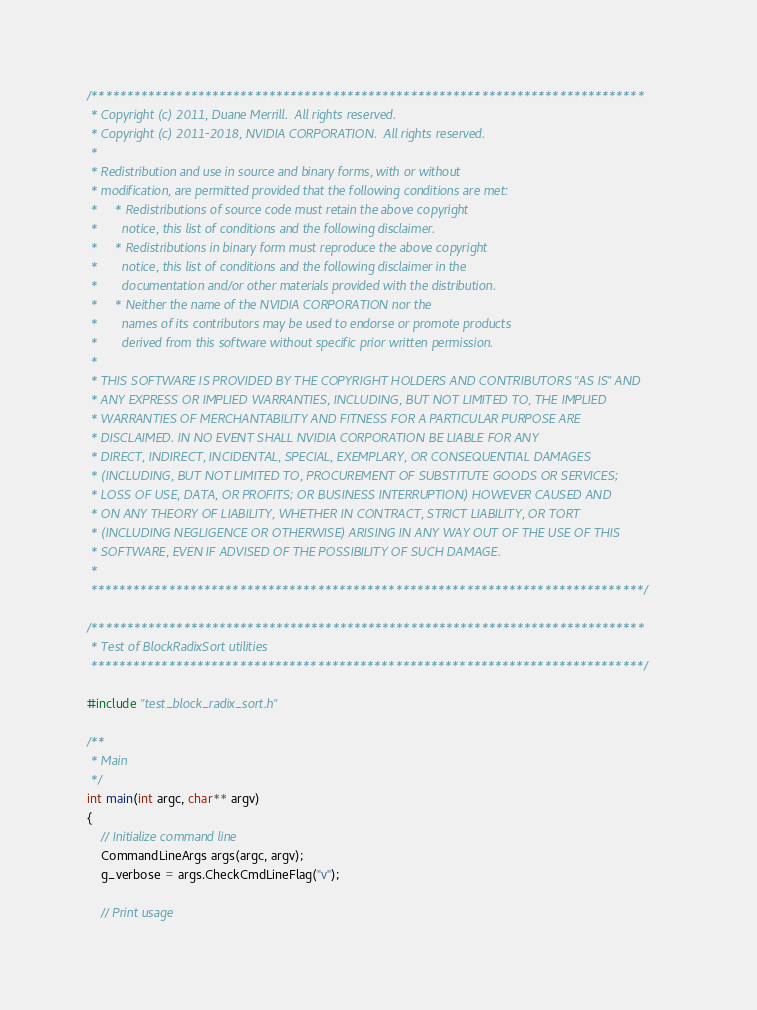Convert code to text. <code><loc_0><loc_0><loc_500><loc_500><_Cuda_>/******************************************************************************
 * Copyright (c) 2011, Duane Merrill.  All rights reserved.
 * Copyright (c) 2011-2018, NVIDIA CORPORATION.  All rights reserved.
 *
 * Redistribution and use in source and binary forms, with or without
 * modification, are permitted provided that the following conditions are met:
 *     * Redistributions of source code must retain the above copyright
 *       notice, this list of conditions and the following disclaimer.
 *     * Redistributions in binary form must reproduce the above copyright
 *       notice, this list of conditions and the following disclaimer in the
 *       documentation and/or other materials provided with the distribution.
 *     * Neither the name of the NVIDIA CORPORATION nor the
 *       names of its contributors may be used to endorse or promote products
 *       derived from this software without specific prior written permission.
 *
 * THIS SOFTWARE IS PROVIDED BY THE COPYRIGHT HOLDERS AND CONTRIBUTORS "AS IS" AND
 * ANY EXPRESS OR IMPLIED WARRANTIES, INCLUDING, BUT NOT LIMITED TO, THE IMPLIED
 * WARRANTIES OF MERCHANTABILITY AND FITNESS FOR A PARTICULAR PURPOSE ARE
 * DISCLAIMED. IN NO EVENT SHALL NVIDIA CORPORATION BE LIABLE FOR ANY
 * DIRECT, INDIRECT, INCIDENTAL, SPECIAL, EXEMPLARY, OR CONSEQUENTIAL DAMAGES
 * (INCLUDING, BUT NOT LIMITED TO, PROCUREMENT OF SUBSTITUTE GOODS OR SERVICES;
 * LOSS OF USE, DATA, OR PROFITS; OR BUSINESS INTERRUPTION) HOWEVER CAUSED AND
 * ON ANY THEORY OF LIABILITY, WHETHER IN CONTRACT, STRICT LIABILITY, OR TORT
 * (INCLUDING NEGLIGENCE OR OTHERWISE) ARISING IN ANY WAY OUT OF THE USE OF THIS
 * SOFTWARE, EVEN IF ADVISED OF THE POSSIBILITY OF SUCH DAMAGE.
 *
 ******************************************************************************/

/******************************************************************************
 * Test of BlockRadixSort utilities
 ******************************************************************************/

#include "test_block_radix_sort.h"

/**
 * Main
 */
int main(int argc, char** argv)
{
    // Initialize command line
    CommandLineArgs args(argc, argv);
    g_verbose = args.CheckCmdLineFlag("v");

    // Print usage</code> 